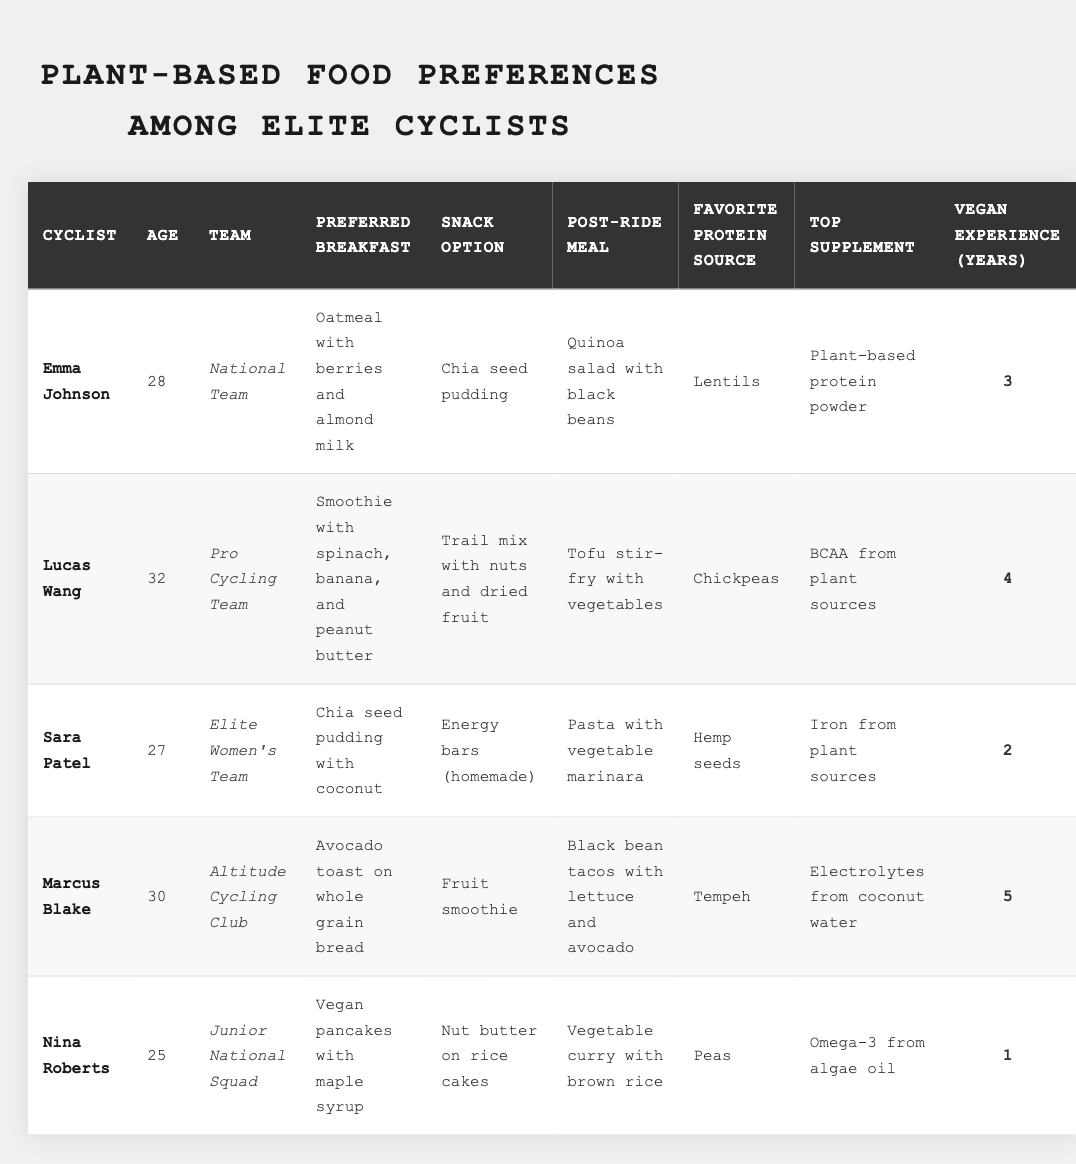What is the preferred breakfast of Emma Johnson? The table lists Emma Johnson's preferred breakfast option under the "Preferred Breakfast" column, which states "Oatmeal with berries and almond milk."
Answer: Oatmeal with berries and almond milk How many years of vegan experience does Marcus Blake have? The table shows Marcus Blake's vegan experience under the "Vegan Experience (Years)" column, which indicates he has 5 years of experience.
Answer: 5 Which cyclist has the favorite protein source of chickpeas? By referring to the "Favorite Protein Source" column, Lucas Wang is identified as having chickpeas as his favorite source of protein.
Answer: Lucas Wang What is the average age of the cyclists listed in the table? The ages of the cyclists are 28, 32, 27, 30, and 25. Summing these gives 28 + 32 + 27 + 30 + 25 = 142. Dividing by the number of cyclists (5), the average age is 142 / 5 = 28.4.
Answer: 28.4 Which team does Nina Roberts belong to? The table indicates under the "Team" column that Nina Roberts is part of the "Junior National Squad."
Answer: Junior National Squad Is Sara Patel's top supplement derived from plant sources? The table lists "Iron from plant sources" as Sara Patel's top supplement, confirming that it is indeed derived from plant sources.
Answer: Yes Who has the highest vegan experience among the cyclists? The vegan experience years listed are 3, 4, 2, 5, and 1. Comparing these values shows that Marcus Blake has the highest at 5 years.
Answer: Marcus Blake What is the post-ride meal preferred by Lucas Wang? Looking at the "Post-Ride Meal" column, it is stated that Lucas Wang prefers a "Tofu stir-fry with vegetables."
Answer: Tofu stir-fry with vegetables Which cyclist has the least vegan experience and how many years? The least vegan experience among the cyclists is found by comparing the years listed. Nina Roberts has 1 year, which is the lowest.
Answer: 1 year Does every cyclist listed have a preferred snack option? The table lists a snack option for each cyclist, confirming that indeed every cyclist has a preferred snack option.
Answer: Yes Calculate the difference in vegan experience between Marcus Blake and Nina Roberts. Marcus Blake has 5 years of vegan experience and Nina Roberts has 1 year. The difference is 5 - 1 = 4 years.
Answer: 4 years 